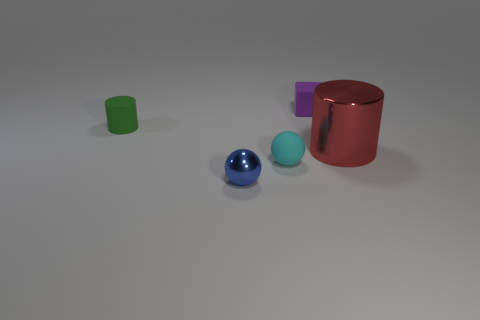Add 5 gray things. How many objects exist? 10 Subtract all cubes. How many objects are left? 4 Add 1 blue metal balls. How many blue metal balls are left? 2 Add 1 tiny blue balls. How many tiny blue balls exist? 2 Subtract 0 yellow cylinders. How many objects are left? 5 Subtract all tiny rubber cylinders. Subtract all green objects. How many objects are left? 3 